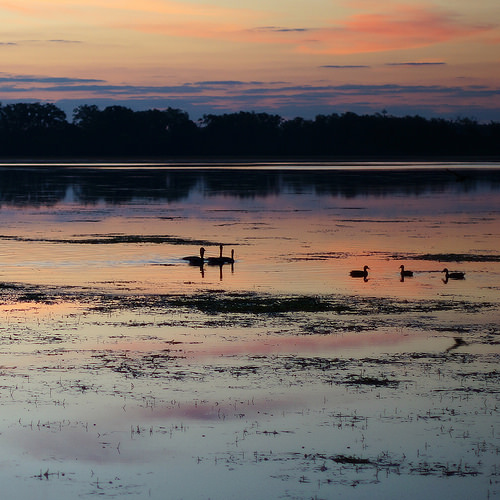<image>
Can you confirm if the ducks is in the air? No. The ducks is not contained within the air. These objects have a different spatial relationship. 